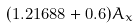Convert formula to latex. <formula><loc_0><loc_0><loc_500><loc_500>( 1 . 2 1 6 8 8 + 0 . 6 ) A _ { x }</formula> 